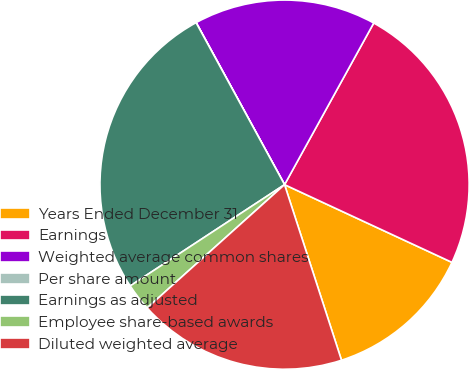<chart> <loc_0><loc_0><loc_500><loc_500><pie_chart><fcel>Years Ended December 31<fcel>Earnings<fcel>Weighted average common shares<fcel>Per share amount<fcel>Earnings as adjusted<fcel>Employee share-based awards<fcel>Diluted weighted average<nl><fcel>13.09%<fcel>23.89%<fcel>15.97%<fcel>0.01%<fcel>26.28%<fcel>2.4%<fcel>18.35%<nl></chart> 